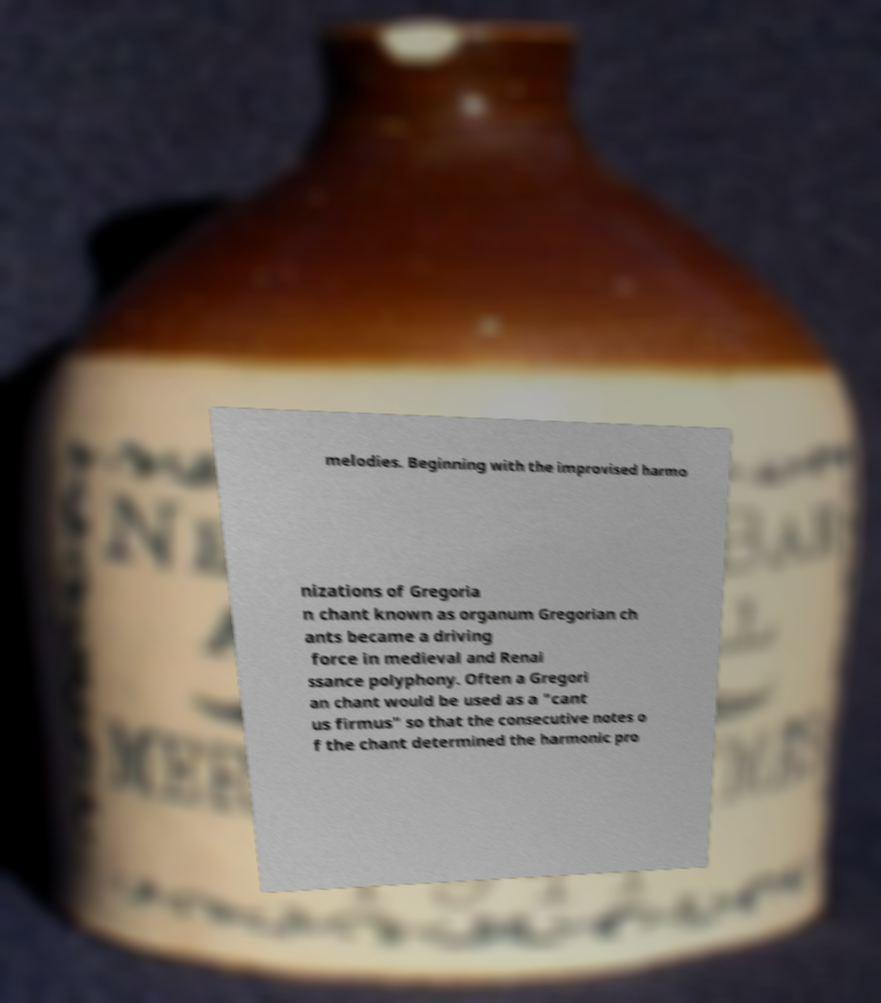For documentation purposes, I need the text within this image transcribed. Could you provide that? melodies. Beginning with the improvised harmo nizations of Gregoria n chant known as organum Gregorian ch ants became a driving force in medieval and Renai ssance polyphony. Often a Gregori an chant would be used as a "cant us firmus" so that the consecutive notes o f the chant determined the harmonic pro 